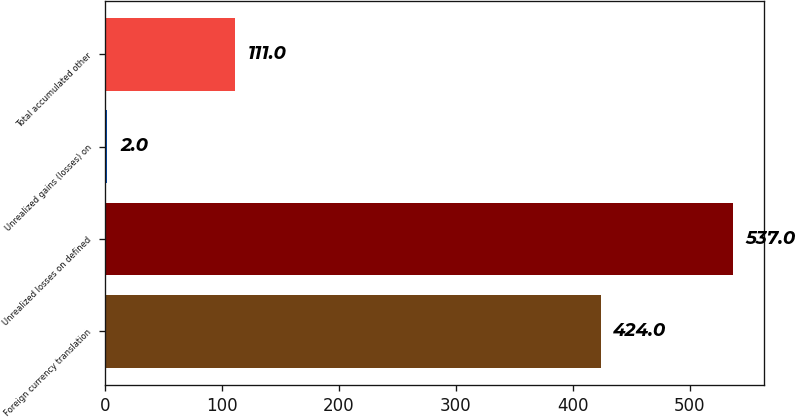Convert chart. <chart><loc_0><loc_0><loc_500><loc_500><bar_chart><fcel>Foreign currency translation<fcel>Unrealized losses on defined<fcel>Unrealized gains (losses) on<fcel>Total accumulated other<nl><fcel>424<fcel>537<fcel>2<fcel>111<nl></chart> 